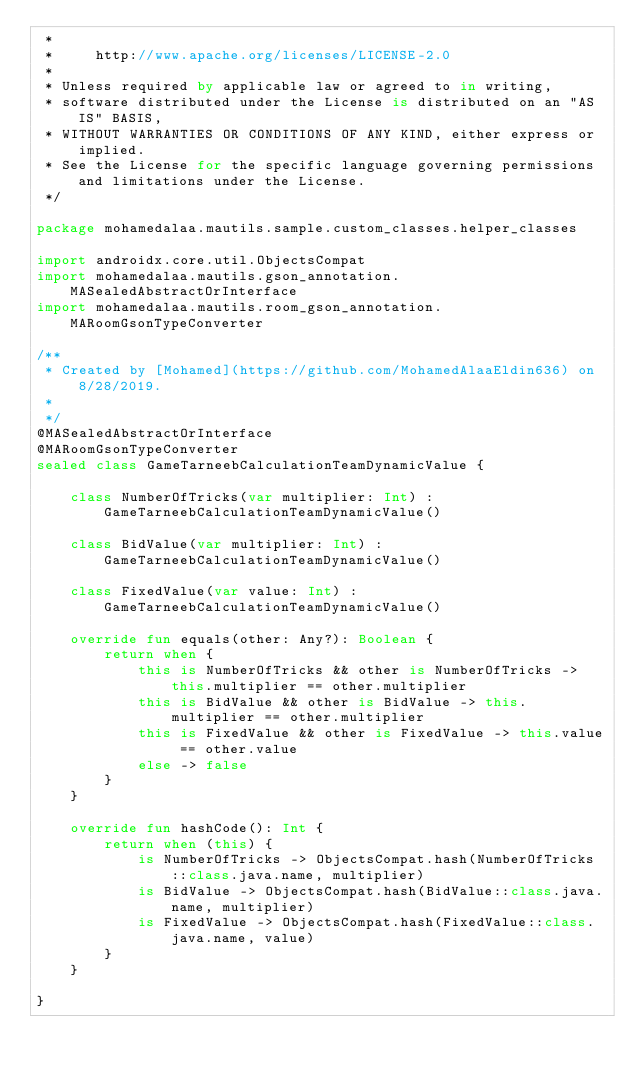Convert code to text. <code><loc_0><loc_0><loc_500><loc_500><_Kotlin_> *
 *     http://www.apache.org/licenses/LICENSE-2.0
 *
 * Unless required by applicable law or agreed to in writing,
 * software distributed under the License is distributed on an "AS IS" BASIS,
 * WITHOUT WARRANTIES OR CONDITIONS OF ANY KIND, either express or implied.
 * See the License for the specific language governing permissions and limitations under the License.
 */

package mohamedalaa.mautils.sample.custom_classes.helper_classes

import androidx.core.util.ObjectsCompat
import mohamedalaa.mautils.gson_annotation.MASealedAbstractOrInterface
import mohamedalaa.mautils.room_gson_annotation.MARoomGsonTypeConverter

/**
 * Created by [Mohamed](https://github.com/MohamedAlaaEldin636) on 8/28/2019.
 *
 */
@MASealedAbstractOrInterface
@MARoomGsonTypeConverter
sealed class GameTarneebCalculationTeamDynamicValue {

    class NumberOfTricks(var multiplier: Int) : GameTarneebCalculationTeamDynamicValue()

    class BidValue(var multiplier: Int) : GameTarneebCalculationTeamDynamicValue()

    class FixedValue(var value: Int) : GameTarneebCalculationTeamDynamicValue()

    override fun equals(other: Any?): Boolean {
        return when {
            this is NumberOfTricks && other is NumberOfTricks -> this.multiplier == other.multiplier
            this is BidValue && other is BidValue -> this.multiplier == other.multiplier
            this is FixedValue && other is FixedValue -> this.value == other.value
            else -> false
        }
    }

    override fun hashCode(): Int {
        return when (this) {
            is NumberOfTricks -> ObjectsCompat.hash(NumberOfTricks::class.java.name, multiplier)
            is BidValue -> ObjectsCompat.hash(BidValue::class.java.name, multiplier)
            is FixedValue -> ObjectsCompat.hash(FixedValue::class.java.name, value)
        }
    }

}</code> 